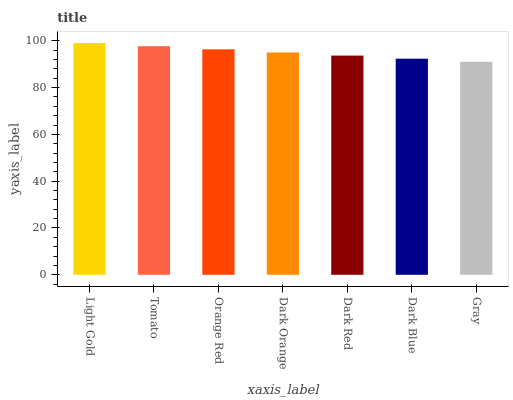Is Gray the minimum?
Answer yes or no. Yes. Is Light Gold the maximum?
Answer yes or no. Yes. Is Tomato the minimum?
Answer yes or no. No. Is Tomato the maximum?
Answer yes or no. No. Is Light Gold greater than Tomato?
Answer yes or no. Yes. Is Tomato less than Light Gold?
Answer yes or no. Yes. Is Tomato greater than Light Gold?
Answer yes or no. No. Is Light Gold less than Tomato?
Answer yes or no. No. Is Dark Orange the high median?
Answer yes or no. Yes. Is Dark Orange the low median?
Answer yes or no. Yes. Is Orange Red the high median?
Answer yes or no. No. Is Dark Red the low median?
Answer yes or no. No. 